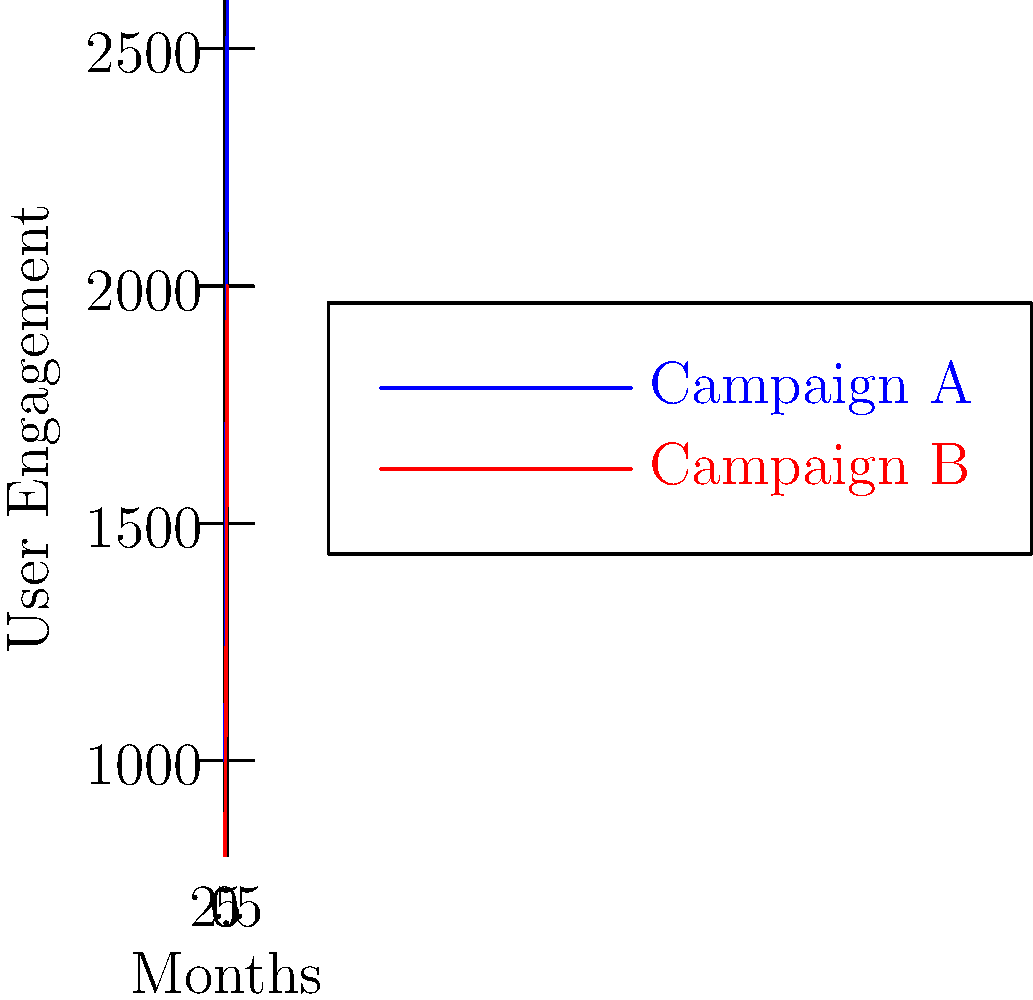You're analyzing user engagement trends for two VK marketing campaigns over a 6-month period. The blue line represents Campaign A, and the red line represents Campaign B. Calculate the average monthly growth rate for Campaign A and determine in which month Campaign B's engagement surpassed 1500 users. To solve this problem, we need to follow these steps:

1. Calculate the average monthly growth rate for Campaign A:
   a. Total growth = Final value - Initial value
      = 2600 - 1000 = 1600
   b. Number of periods = 6 - 1 = 5 (as we're calculating growth between months)
   c. Average monthly growth = Total growth / Number of periods
      = 1600 / 5 = 320 users per month

2. Determine when Campaign B surpassed 1500 users:
   Month 0: 800 < 1500
   Month 1: 950 < 1500
   Month 2: 1100 < 1500
   Month 3: 1300 < 1500
   Month 4: 1600 > 1500

Campaign B surpassed 1500 users in Month 4.
Answer: 320 users/month; Month 4 